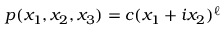<formula> <loc_0><loc_0><loc_500><loc_500>p ( x _ { 1 } , x _ { 2 } , x _ { 3 } ) = c ( x _ { 1 } + i x _ { 2 } ) ^ { \ell }</formula> 